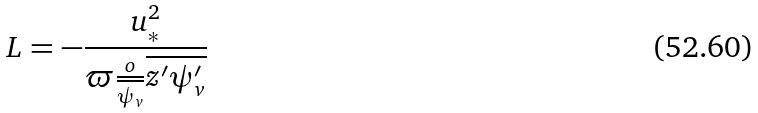<formula> <loc_0><loc_0><loc_500><loc_500>L = - \frac { u _ { * } ^ { 2 } } { \varpi \frac { o } { \overline { \psi _ { v } } } \overline { z ^ { \prime } \psi _ { v } ^ { \prime } } }</formula> 